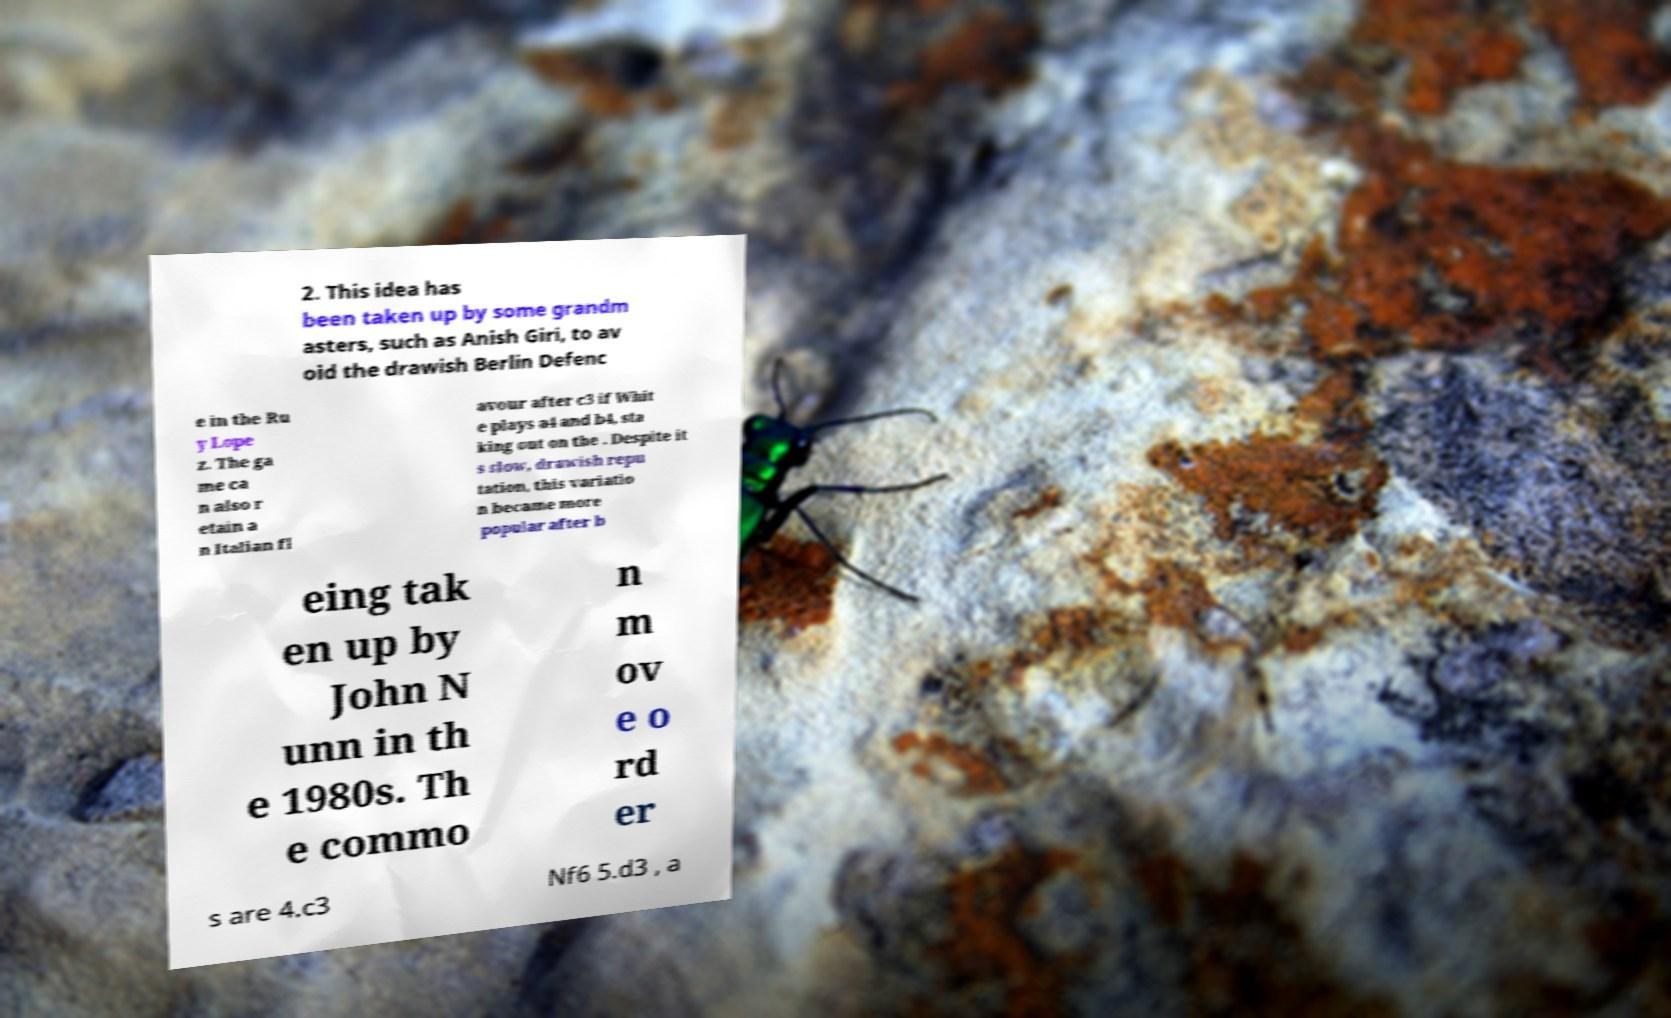Can you accurately transcribe the text from the provided image for me? 2. This idea has been taken up by some grandm asters, such as Anish Giri, to av oid the drawish Berlin Defenc e in the Ru y Lope z. The ga me ca n also r etain a n Italian fl avour after c3 if Whit e plays a4 and b4, sta king out on the . Despite it s slow, drawish repu tation, this variatio n became more popular after b eing tak en up by John N unn in th e 1980s. Th e commo n m ov e o rd er s are 4.c3 Nf6 5.d3 , a 